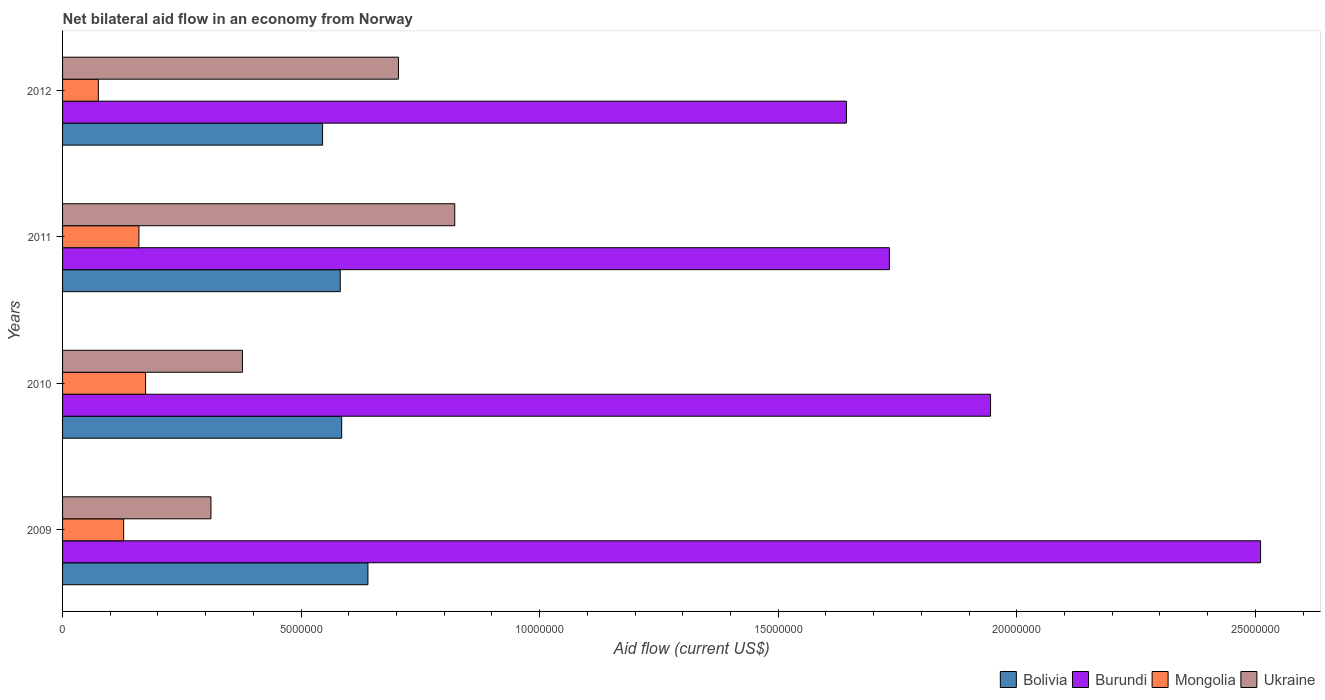Are the number of bars on each tick of the Y-axis equal?
Your answer should be compact. Yes. What is the label of the 3rd group of bars from the top?
Offer a terse response. 2010. What is the net bilateral aid flow in Ukraine in 2011?
Offer a terse response. 8.22e+06. Across all years, what is the maximum net bilateral aid flow in Ukraine?
Your response must be concise. 8.22e+06. Across all years, what is the minimum net bilateral aid flow in Bolivia?
Give a very brief answer. 5.45e+06. What is the total net bilateral aid flow in Bolivia in the graph?
Your answer should be compact. 2.35e+07. What is the difference between the net bilateral aid flow in Burundi in 2009 and that in 2012?
Make the answer very short. 8.68e+06. What is the difference between the net bilateral aid flow in Mongolia in 2010 and the net bilateral aid flow in Burundi in 2009?
Your answer should be compact. -2.34e+07. What is the average net bilateral aid flow in Bolivia per year?
Give a very brief answer. 5.88e+06. In the year 2010, what is the difference between the net bilateral aid flow in Mongolia and net bilateral aid flow in Ukraine?
Give a very brief answer. -2.03e+06. In how many years, is the net bilateral aid flow in Burundi greater than 10000000 US$?
Offer a very short reply. 4. What is the ratio of the net bilateral aid flow in Bolivia in 2010 to that in 2012?
Provide a succinct answer. 1.07. Is the net bilateral aid flow in Mongolia in 2011 less than that in 2012?
Your answer should be compact. No. Is the difference between the net bilateral aid flow in Mongolia in 2010 and 2011 greater than the difference between the net bilateral aid flow in Ukraine in 2010 and 2011?
Keep it short and to the point. Yes. What is the difference between the highest and the second highest net bilateral aid flow in Mongolia?
Keep it short and to the point. 1.40e+05. What is the difference between the highest and the lowest net bilateral aid flow in Burundi?
Provide a short and direct response. 8.68e+06. Is the sum of the net bilateral aid flow in Ukraine in 2010 and 2012 greater than the maximum net bilateral aid flow in Mongolia across all years?
Offer a terse response. Yes. Is it the case that in every year, the sum of the net bilateral aid flow in Bolivia and net bilateral aid flow in Mongolia is greater than the sum of net bilateral aid flow in Ukraine and net bilateral aid flow in Burundi?
Provide a succinct answer. No. What does the 4th bar from the top in 2011 represents?
Your answer should be compact. Bolivia. What does the 1st bar from the bottom in 2012 represents?
Offer a terse response. Bolivia. How many bars are there?
Offer a very short reply. 16. What is the difference between two consecutive major ticks on the X-axis?
Provide a succinct answer. 5.00e+06. Are the values on the major ticks of X-axis written in scientific E-notation?
Offer a terse response. No. Does the graph contain any zero values?
Make the answer very short. No. How are the legend labels stacked?
Offer a very short reply. Horizontal. What is the title of the graph?
Ensure brevity in your answer.  Net bilateral aid flow in an economy from Norway. Does "Monaco" appear as one of the legend labels in the graph?
Make the answer very short. No. What is the label or title of the X-axis?
Your response must be concise. Aid flow (current US$). What is the label or title of the Y-axis?
Ensure brevity in your answer.  Years. What is the Aid flow (current US$) of Bolivia in 2009?
Make the answer very short. 6.40e+06. What is the Aid flow (current US$) of Burundi in 2009?
Offer a terse response. 2.51e+07. What is the Aid flow (current US$) of Mongolia in 2009?
Ensure brevity in your answer.  1.28e+06. What is the Aid flow (current US$) of Ukraine in 2009?
Ensure brevity in your answer.  3.11e+06. What is the Aid flow (current US$) in Bolivia in 2010?
Provide a short and direct response. 5.85e+06. What is the Aid flow (current US$) in Burundi in 2010?
Make the answer very short. 1.94e+07. What is the Aid flow (current US$) of Mongolia in 2010?
Offer a very short reply. 1.74e+06. What is the Aid flow (current US$) in Ukraine in 2010?
Provide a short and direct response. 3.77e+06. What is the Aid flow (current US$) of Bolivia in 2011?
Provide a succinct answer. 5.82e+06. What is the Aid flow (current US$) in Burundi in 2011?
Your answer should be very brief. 1.73e+07. What is the Aid flow (current US$) in Mongolia in 2011?
Your answer should be very brief. 1.60e+06. What is the Aid flow (current US$) in Ukraine in 2011?
Your answer should be compact. 8.22e+06. What is the Aid flow (current US$) in Bolivia in 2012?
Offer a terse response. 5.45e+06. What is the Aid flow (current US$) in Burundi in 2012?
Your answer should be very brief. 1.64e+07. What is the Aid flow (current US$) of Mongolia in 2012?
Your response must be concise. 7.50e+05. What is the Aid flow (current US$) of Ukraine in 2012?
Ensure brevity in your answer.  7.04e+06. Across all years, what is the maximum Aid flow (current US$) in Bolivia?
Give a very brief answer. 6.40e+06. Across all years, what is the maximum Aid flow (current US$) of Burundi?
Your response must be concise. 2.51e+07. Across all years, what is the maximum Aid flow (current US$) in Mongolia?
Keep it short and to the point. 1.74e+06. Across all years, what is the maximum Aid flow (current US$) of Ukraine?
Keep it short and to the point. 8.22e+06. Across all years, what is the minimum Aid flow (current US$) of Bolivia?
Make the answer very short. 5.45e+06. Across all years, what is the minimum Aid flow (current US$) in Burundi?
Offer a very short reply. 1.64e+07. Across all years, what is the minimum Aid flow (current US$) of Mongolia?
Offer a very short reply. 7.50e+05. Across all years, what is the minimum Aid flow (current US$) of Ukraine?
Your answer should be very brief. 3.11e+06. What is the total Aid flow (current US$) of Bolivia in the graph?
Offer a very short reply. 2.35e+07. What is the total Aid flow (current US$) in Burundi in the graph?
Your answer should be very brief. 7.83e+07. What is the total Aid flow (current US$) in Mongolia in the graph?
Your answer should be very brief. 5.37e+06. What is the total Aid flow (current US$) in Ukraine in the graph?
Give a very brief answer. 2.21e+07. What is the difference between the Aid flow (current US$) in Burundi in 2009 and that in 2010?
Offer a terse response. 5.66e+06. What is the difference between the Aid flow (current US$) in Mongolia in 2009 and that in 2010?
Offer a very short reply. -4.60e+05. What is the difference between the Aid flow (current US$) of Ukraine in 2009 and that in 2010?
Your answer should be compact. -6.60e+05. What is the difference between the Aid flow (current US$) of Bolivia in 2009 and that in 2011?
Offer a terse response. 5.80e+05. What is the difference between the Aid flow (current US$) in Burundi in 2009 and that in 2011?
Give a very brief answer. 7.78e+06. What is the difference between the Aid flow (current US$) in Mongolia in 2009 and that in 2011?
Offer a very short reply. -3.20e+05. What is the difference between the Aid flow (current US$) in Ukraine in 2009 and that in 2011?
Provide a succinct answer. -5.11e+06. What is the difference between the Aid flow (current US$) in Bolivia in 2009 and that in 2012?
Ensure brevity in your answer.  9.50e+05. What is the difference between the Aid flow (current US$) in Burundi in 2009 and that in 2012?
Your response must be concise. 8.68e+06. What is the difference between the Aid flow (current US$) in Mongolia in 2009 and that in 2012?
Offer a terse response. 5.30e+05. What is the difference between the Aid flow (current US$) of Ukraine in 2009 and that in 2012?
Keep it short and to the point. -3.93e+06. What is the difference between the Aid flow (current US$) of Bolivia in 2010 and that in 2011?
Make the answer very short. 3.00e+04. What is the difference between the Aid flow (current US$) of Burundi in 2010 and that in 2011?
Your response must be concise. 2.12e+06. What is the difference between the Aid flow (current US$) in Mongolia in 2010 and that in 2011?
Offer a terse response. 1.40e+05. What is the difference between the Aid flow (current US$) of Ukraine in 2010 and that in 2011?
Keep it short and to the point. -4.45e+06. What is the difference between the Aid flow (current US$) in Bolivia in 2010 and that in 2012?
Your answer should be compact. 4.00e+05. What is the difference between the Aid flow (current US$) in Burundi in 2010 and that in 2012?
Offer a terse response. 3.02e+06. What is the difference between the Aid flow (current US$) in Mongolia in 2010 and that in 2012?
Offer a terse response. 9.90e+05. What is the difference between the Aid flow (current US$) of Ukraine in 2010 and that in 2012?
Your response must be concise. -3.27e+06. What is the difference between the Aid flow (current US$) of Mongolia in 2011 and that in 2012?
Provide a short and direct response. 8.50e+05. What is the difference between the Aid flow (current US$) of Ukraine in 2011 and that in 2012?
Your answer should be very brief. 1.18e+06. What is the difference between the Aid flow (current US$) of Bolivia in 2009 and the Aid flow (current US$) of Burundi in 2010?
Offer a terse response. -1.30e+07. What is the difference between the Aid flow (current US$) in Bolivia in 2009 and the Aid flow (current US$) in Mongolia in 2010?
Give a very brief answer. 4.66e+06. What is the difference between the Aid flow (current US$) of Bolivia in 2009 and the Aid flow (current US$) of Ukraine in 2010?
Make the answer very short. 2.63e+06. What is the difference between the Aid flow (current US$) in Burundi in 2009 and the Aid flow (current US$) in Mongolia in 2010?
Your answer should be very brief. 2.34e+07. What is the difference between the Aid flow (current US$) of Burundi in 2009 and the Aid flow (current US$) of Ukraine in 2010?
Provide a succinct answer. 2.13e+07. What is the difference between the Aid flow (current US$) in Mongolia in 2009 and the Aid flow (current US$) in Ukraine in 2010?
Your response must be concise. -2.49e+06. What is the difference between the Aid flow (current US$) of Bolivia in 2009 and the Aid flow (current US$) of Burundi in 2011?
Offer a terse response. -1.09e+07. What is the difference between the Aid flow (current US$) of Bolivia in 2009 and the Aid flow (current US$) of Mongolia in 2011?
Give a very brief answer. 4.80e+06. What is the difference between the Aid flow (current US$) in Bolivia in 2009 and the Aid flow (current US$) in Ukraine in 2011?
Give a very brief answer. -1.82e+06. What is the difference between the Aid flow (current US$) of Burundi in 2009 and the Aid flow (current US$) of Mongolia in 2011?
Your answer should be very brief. 2.35e+07. What is the difference between the Aid flow (current US$) of Burundi in 2009 and the Aid flow (current US$) of Ukraine in 2011?
Your response must be concise. 1.69e+07. What is the difference between the Aid flow (current US$) of Mongolia in 2009 and the Aid flow (current US$) of Ukraine in 2011?
Your answer should be very brief. -6.94e+06. What is the difference between the Aid flow (current US$) of Bolivia in 2009 and the Aid flow (current US$) of Burundi in 2012?
Provide a succinct answer. -1.00e+07. What is the difference between the Aid flow (current US$) of Bolivia in 2009 and the Aid flow (current US$) of Mongolia in 2012?
Ensure brevity in your answer.  5.65e+06. What is the difference between the Aid flow (current US$) in Bolivia in 2009 and the Aid flow (current US$) in Ukraine in 2012?
Offer a terse response. -6.40e+05. What is the difference between the Aid flow (current US$) of Burundi in 2009 and the Aid flow (current US$) of Mongolia in 2012?
Give a very brief answer. 2.44e+07. What is the difference between the Aid flow (current US$) of Burundi in 2009 and the Aid flow (current US$) of Ukraine in 2012?
Provide a short and direct response. 1.81e+07. What is the difference between the Aid flow (current US$) in Mongolia in 2009 and the Aid flow (current US$) in Ukraine in 2012?
Provide a succinct answer. -5.76e+06. What is the difference between the Aid flow (current US$) of Bolivia in 2010 and the Aid flow (current US$) of Burundi in 2011?
Ensure brevity in your answer.  -1.15e+07. What is the difference between the Aid flow (current US$) of Bolivia in 2010 and the Aid flow (current US$) of Mongolia in 2011?
Give a very brief answer. 4.25e+06. What is the difference between the Aid flow (current US$) of Bolivia in 2010 and the Aid flow (current US$) of Ukraine in 2011?
Provide a short and direct response. -2.37e+06. What is the difference between the Aid flow (current US$) of Burundi in 2010 and the Aid flow (current US$) of Mongolia in 2011?
Give a very brief answer. 1.78e+07. What is the difference between the Aid flow (current US$) of Burundi in 2010 and the Aid flow (current US$) of Ukraine in 2011?
Provide a short and direct response. 1.12e+07. What is the difference between the Aid flow (current US$) in Mongolia in 2010 and the Aid flow (current US$) in Ukraine in 2011?
Offer a terse response. -6.48e+06. What is the difference between the Aid flow (current US$) of Bolivia in 2010 and the Aid flow (current US$) of Burundi in 2012?
Ensure brevity in your answer.  -1.06e+07. What is the difference between the Aid flow (current US$) in Bolivia in 2010 and the Aid flow (current US$) in Mongolia in 2012?
Offer a terse response. 5.10e+06. What is the difference between the Aid flow (current US$) of Bolivia in 2010 and the Aid flow (current US$) of Ukraine in 2012?
Your response must be concise. -1.19e+06. What is the difference between the Aid flow (current US$) of Burundi in 2010 and the Aid flow (current US$) of Mongolia in 2012?
Offer a very short reply. 1.87e+07. What is the difference between the Aid flow (current US$) in Burundi in 2010 and the Aid flow (current US$) in Ukraine in 2012?
Provide a short and direct response. 1.24e+07. What is the difference between the Aid flow (current US$) in Mongolia in 2010 and the Aid flow (current US$) in Ukraine in 2012?
Make the answer very short. -5.30e+06. What is the difference between the Aid flow (current US$) of Bolivia in 2011 and the Aid flow (current US$) of Burundi in 2012?
Ensure brevity in your answer.  -1.06e+07. What is the difference between the Aid flow (current US$) of Bolivia in 2011 and the Aid flow (current US$) of Mongolia in 2012?
Provide a succinct answer. 5.07e+06. What is the difference between the Aid flow (current US$) in Bolivia in 2011 and the Aid flow (current US$) in Ukraine in 2012?
Ensure brevity in your answer.  -1.22e+06. What is the difference between the Aid flow (current US$) in Burundi in 2011 and the Aid flow (current US$) in Mongolia in 2012?
Provide a short and direct response. 1.66e+07. What is the difference between the Aid flow (current US$) in Burundi in 2011 and the Aid flow (current US$) in Ukraine in 2012?
Offer a very short reply. 1.03e+07. What is the difference between the Aid flow (current US$) of Mongolia in 2011 and the Aid flow (current US$) of Ukraine in 2012?
Ensure brevity in your answer.  -5.44e+06. What is the average Aid flow (current US$) of Bolivia per year?
Offer a very short reply. 5.88e+06. What is the average Aid flow (current US$) in Burundi per year?
Offer a very short reply. 1.96e+07. What is the average Aid flow (current US$) of Mongolia per year?
Your answer should be compact. 1.34e+06. What is the average Aid flow (current US$) of Ukraine per year?
Give a very brief answer. 5.54e+06. In the year 2009, what is the difference between the Aid flow (current US$) in Bolivia and Aid flow (current US$) in Burundi?
Offer a very short reply. -1.87e+07. In the year 2009, what is the difference between the Aid flow (current US$) of Bolivia and Aid flow (current US$) of Mongolia?
Provide a succinct answer. 5.12e+06. In the year 2009, what is the difference between the Aid flow (current US$) in Bolivia and Aid flow (current US$) in Ukraine?
Your response must be concise. 3.29e+06. In the year 2009, what is the difference between the Aid flow (current US$) of Burundi and Aid flow (current US$) of Mongolia?
Offer a very short reply. 2.38e+07. In the year 2009, what is the difference between the Aid flow (current US$) in Burundi and Aid flow (current US$) in Ukraine?
Give a very brief answer. 2.20e+07. In the year 2009, what is the difference between the Aid flow (current US$) of Mongolia and Aid flow (current US$) of Ukraine?
Give a very brief answer. -1.83e+06. In the year 2010, what is the difference between the Aid flow (current US$) in Bolivia and Aid flow (current US$) in Burundi?
Give a very brief answer. -1.36e+07. In the year 2010, what is the difference between the Aid flow (current US$) in Bolivia and Aid flow (current US$) in Mongolia?
Keep it short and to the point. 4.11e+06. In the year 2010, what is the difference between the Aid flow (current US$) of Bolivia and Aid flow (current US$) of Ukraine?
Offer a terse response. 2.08e+06. In the year 2010, what is the difference between the Aid flow (current US$) in Burundi and Aid flow (current US$) in Mongolia?
Provide a short and direct response. 1.77e+07. In the year 2010, what is the difference between the Aid flow (current US$) of Burundi and Aid flow (current US$) of Ukraine?
Your response must be concise. 1.57e+07. In the year 2010, what is the difference between the Aid flow (current US$) of Mongolia and Aid flow (current US$) of Ukraine?
Ensure brevity in your answer.  -2.03e+06. In the year 2011, what is the difference between the Aid flow (current US$) of Bolivia and Aid flow (current US$) of Burundi?
Your answer should be very brief. -1.15e+07. In the year 2011, what is the difference between the Aid flow (current US$) in Bolivia and Aid flow (current US$) in Mongolia?
Offer a very short reply. 4.22e+06. In the year 2011, what is the difference between the Aid flow (current US$) in Bolivia and Aid flow (current US$) in Ukraine?
Keep it short and to the point. -2.40e+06. In the year 2011, what is the difference between the Aid flow (current US$) of Burundi and Aid flow (current US$) of Mongolia?
Offer a terse response. 1.57e+07. In the year 2011, what is the difference between the Aid flow (current US$) of Burundi and Aid flow (current US$) of Ukraine?
Offer a terse response. 9.11e+06. In the year 2011, what is the difference between the Aid flow (current US$) in Mongolia and Aid flow (current US$) in Ukraine?
Provide a short and direct response. -6.62e+06. In the year 2012, what is the difference between the Aid flow (current US$) in Bolivia and Aid flow (current US$) in Burundi?
Your response must be concise. -1.10e+07. In the year 2012, what is the difference between the Aid flow (current US$) in Bolivia and Aid flow (current US$) in Mongolia?
Make the answer very short. 4.70e+06. In the year 2012, what is the difference between the Aid flow (current US$) of Bolivia and Aid flow (current US$) of Ukraine?
Offer a terse response. -1.59e+06. In the year 2012, what is the difference between the Aid flow (current US$) in Burundi and Aid flow (current US$) in Mongolia?
Your answer should be compact. 1.57e+07. In the year 2012, what is the difference between the Aid flow (current US$) of Burundi and Aid flow (current US$) of Ukraine?
Your answer should be very brief. 9.39e+06. In the year 2012, what is the difference between the Aid flow (current US$) of Mongolia and Aid flow (current US$) of Ukraine?
Ensure brevity in your answer.  -6.29e+06. What is the ratio of the Aid flow (current US$) of Bolivia in 2009 to that in 2010?
Offer a terse response. 1.09. What is the ratio of the Aid flow (current US$) in Burundi in 2009 to that in 2010?
Give a very brief answer. 1.29. What is the ratio of the Aid flow (current US$) of Mongolia in 2009 to that in 2010?
Your answer should be compact. 0.74. What is the ratio of the Aid flow (current US$) in Ukraine in 2009 to that in 2010?
Ensure brevity in your answer.  0.82. What is the ratio of the Aid flow (current US$) of Bolivia in 2009 to that in 2011?
Provide a succinct answer. 1.1. What is the ratio of the Aid flow (current US$) in Burundi in 2009 to that in 2011?
Give a very brief answer. 1.45. What is the ratio of the Aid flow (current US$) in Ukraine in 2009 to that in 2011?
Give a very brief answer. 0.38. What is the ratio of the Aid flow (current US$) of Bolivia in 2009 to that in 2012?
Provide a succinct answer. 1.17. What is the ratio of the Aid flow (current US$) of Burundi in 2009 to that in 2012?
Provide a succinct answer. 1.53. What is the ratio of the Aid flow (current US$) in Mongolia in 2009 to that in 2012?
Your answer should be very brief. 1.71. What is the ratio of the Aid flow (current US$) in Ukraine in 2009 to that in 2012?
Ensure brevity in your answer.  0.44. What is the ratio of the Aid flow (current US$) of Burundi in 2010 to that in 2011?
Give a very brief answer. 1.12. What is the ratio of the Aid flow (current US$) in Mongolia in 2010 to that in 2011?
Make the answer very short. 1.09. What is the ratio of the Aid flow (current US$) in Ukraine in 2010 to that in 2011?
Provide a succinct answer. 0.46. What is the ratio of the Aid flow (current US$) of Bolivia in 2010 to that in 2012?
Ensure brevity in your answer.  1.07. What is the ratio of the Aid flow (current US$) in Burundi in 2010 to that in 2012?
Your answer should be compact. 1.18. What is the ratio of the Aid flow (current US$) in Mongolia in 2010 to that in 2012?
Your answer should be compact. 2.32. What is the ratio of the Aid flow (current US$) of Ukraine in 2010 to that in 2012?
Ensure brevity in your answer.  0.54. What is the ratio of the Aid flow (current US$) of Bolivia in 2011 to that in 2012?
Offer a very short reply. 1.07. What is the ratio of the Aid flow (current US$) in Burundi in 2011 to that in 2012?
Offer a very short reply. 1.05. What is the ratio of the Aid flow (current US$) of Mongolia in 2011 to that in 2012?
Your response must be concise. 2.13. What is the ratio of the Aid flow (current US$) in Ukraine in 2011 to that in 2012?
Make the answer very short. 1.17. What is the difference between the highest and the second highest Aid flow (current US$) in Bolivia?
Provide a succinct answer. 5.50e+05. What is the difference between the highest and the second highest Aid flow (current US$) in Burundi?
Make the answer very short. 5.66e+06. What is the difference between the highest and the second highest Aid flow (current US$) of Mongolia?
Give a very brief answer. 1.40e+05. What is the difference between the highest and the second highest Aid flow (current US$) of Ukraine?
Keep it short and to the point. 1.18e+06. What is the difference between the highest and the lowest Aid flow (current US$) in Bolivia?
Ensure brevity in your answer.  9.50e+05. What is the difference between the highest and the lowest Aid flow (current US$) in Burundi?
Give a very brief answer. 8.68e+06. What is the difference between the highest and the lowest Aid flow (current US$) in Mongolia?
Offer a very short reply. 9.90e+05. What is the difference between the highest and the lowest Aid flow (current US$) of Ukraine?
Offer a very short reply. 5.11e+06. 